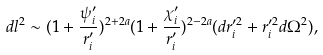<formula> <loc_0><loc_0><loc_500><loc_500>d l ^ { 2 } \sim ( 1 + \frac { \psi _ { i } ^ { \prime } } { r _ { i } ^ { \prime } } ) ^ { 2 + 2 a } ( 1 + \frac { \chi _ { i } ^ { \prime } } { r _ { i } ^ { \prime } } ) ^ { 2 - 2 a } ( d r _ { i } ^ { \prime 2 } + r _ { i } ^ { \prime 2 } d \Omega ^ { 2 } ) ,</formula> 